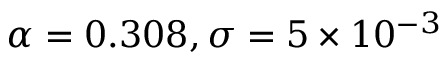<formula> <loc_0><loc_0><loc_500><loc_500>\alpha = 0 . 3 0 8 , \sigma = 5 \times 1 0 ^ { - 3 }</formula> 